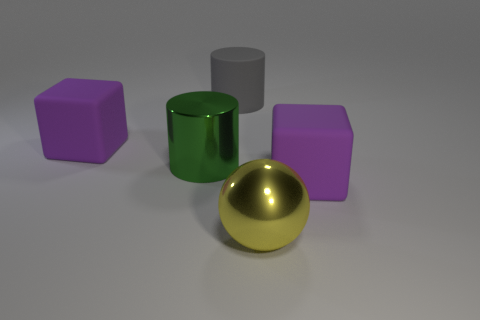Add 2 purple blocks. How many objects exist? 7 Subtract all cylinders. How many objects are left? 3 Add 4 big rubber objects. How many big rubber objects are left? 7 Add 2 big green shiny cylinders. How many big green shiny cylinders exist? 3 Subtract 0 brown cylinders. How many objects are left? 5 Subtract all blocks. Subtract all gray objects. How many objects are left? 2 